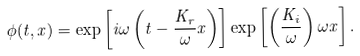<formula> <loc_0><loc_0><loc_500><loc_500>\phi ( t , x ) = \exp \left [ i \omega \left ( t - \frac { K _ { r } } { \omega } x \right ) \right ] \exp \left [ \left ( \frac { K _ { i } } { \omega } \right ) \omega x \right ] .</formula> 